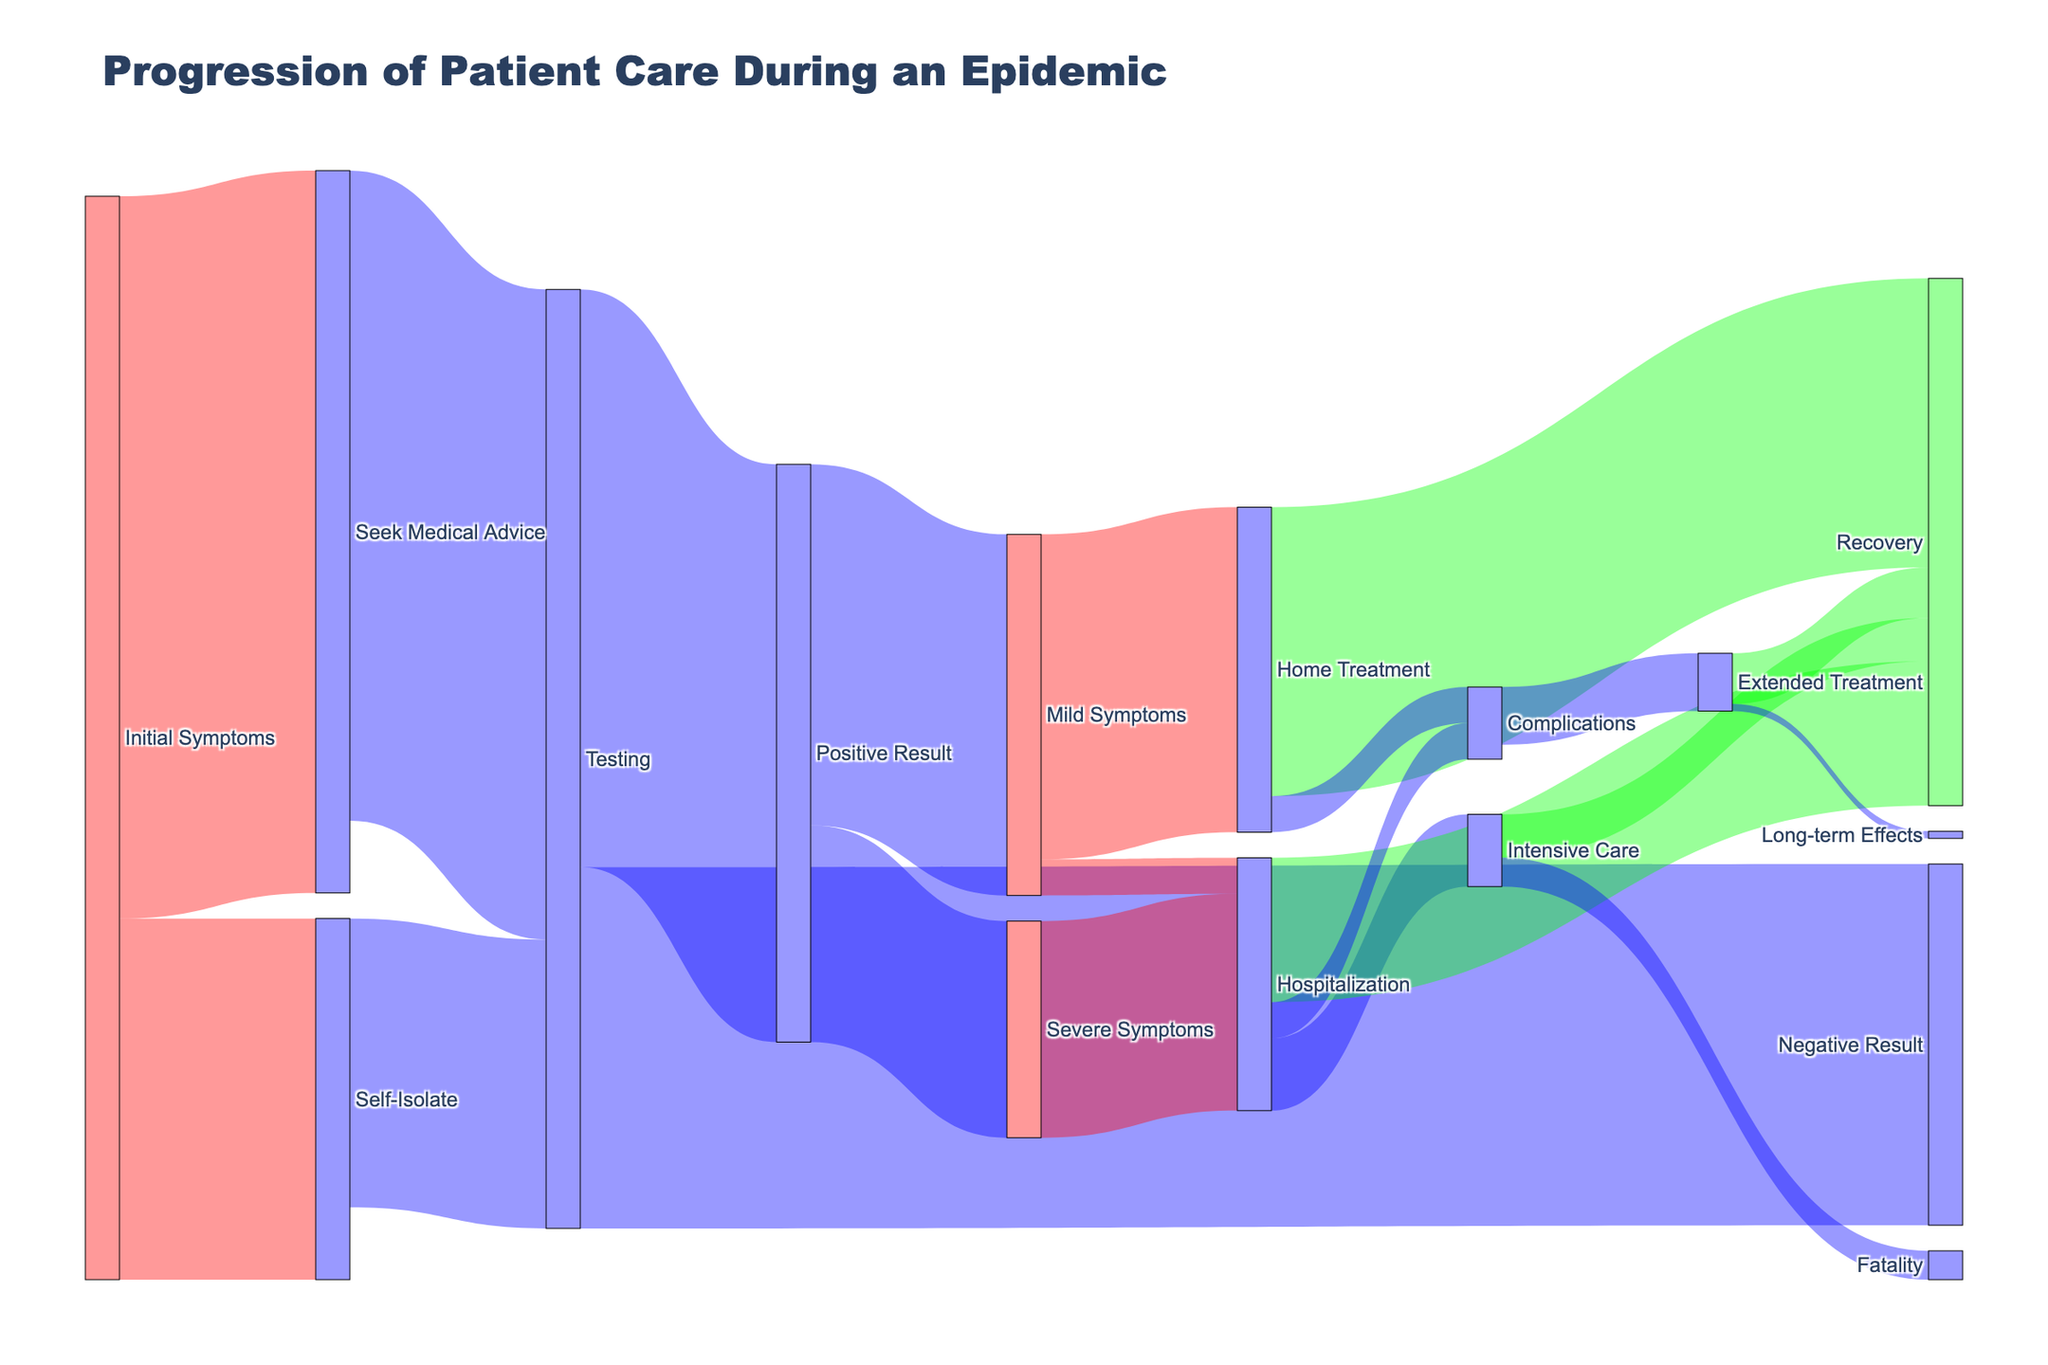How many patients recovered after receiving home treatment? From the chart, follow the flow from "Home Treatment" and see that 400 patients recovered.
Answer: 400 How many patients received testing after seeking medical advice? From the chart, follow the flow that starts at "Seek Medical Advice" and continues to "Testing," which shows 900 patients.
Answer: 900 What is the total number of patients who had complications after home treatment or hospitalization? Sum the values from "Home Treatment" to "Complications" (50) and "Hospitalization" to "Complications" (50). 50 + 50 = 100
Answer: 100 Compare the number of patients who self-isolated with those who sought medical advice for initial symptoms. Which group is larger? Examine the flows from "Initial Symptoms." Those who self-isolated were 500, and those who sought medical advice were 1000. 1000 (Medical Advice) is larger than 500 (Self-Isolate).
Answer: 1000 What is the color used to represent the flow to recovery? The link color rule indicates that the flow to "Recovery" is shown in a green shade. Confirm visually in the diagram to ensure consistency.
Answer: Green What percentage of patients who tested positive had severe symptoms? Identify the total number of patients who tested positive (800) and those who had severe symptoms (300). Compute: (300/800) * 100 = 37.5%
Answer: 37.5% How many patients required intensive care after hospitalization? Check the flow from "Hospitalization" to "Intensive Care," which shows 100 patients.
Answer: 100 Compare the flow from the testing phase: How many more patients received a positive result compared to a negative result? From the testing phase, 800 received a positive result and 500 received a negative result. Subtract to get the difference: 800 - 500 = 300
Answer: 300 After home treatment, how many patients faced complications compared to those who recovered? Check the flows from "Home Treatment" to "Complications" (50) and to "Recovery" (400). Compare the two values: 400 recovered and 50 faced complications, thus 400 is larger than 50.
Answer: 400 What subsequent path had the least number of patients, and how many were there? Analyze all the paths and find the smallest value, which can be seen in "Extended Treatment" to "Long-term Effects" with 10 patients.
Answer: 10 